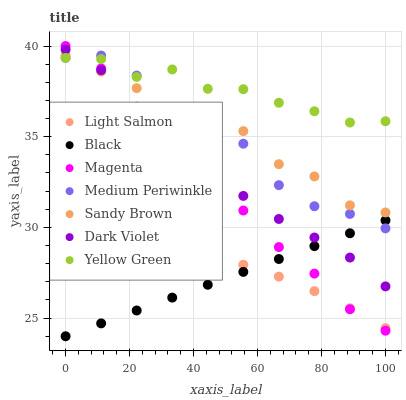Does Black have the minimum area under the curve?
Answer yes or no. Yes. Does Yellow Green have the maximum area under the curve?
Answer yes or no. Yes. Does Medium Periwinkle have the minimum area under the curve?
Answer yes or no. No. Does Medium Periwinkle have the maximum area under the curve?
Answer yes or no. No. Is Black the smoothest?
Answer yes or no. Yes. Is Medium Periwinkle the roughest?
Answer yes or no. Yes. Is Yellow Green the smoothest?
Answer yes or no. No. Is Yellow Green the roughest?
Answer yes or no. No. Does Black have the lowest value?
Answer yes or no. Yes. Does Medium Periwinkle have the lowest value?
Answer yes or no. No. Does Magenta have the highest value?
Answer yes or no. Yes. Does Yellow Green have the highest value?
Answer yes or no. No. Is Light Salmon less than Yellow Green?
Answer yes or no. Yes. Is Sandy Brown greater than Light Salmon?
Answer yes or no. Yes. Does Medium Periwinkle intersect Magenta?
Answer yes or no. Yes. Is Medium Periwinkle less than Magenta?
Answer yes or no. No. Is Medium Periwinkle greater than Magenta?
Answer yes or no. No. Does Light Salmon intersect Yellow Green?
Answer yes or no. No. 